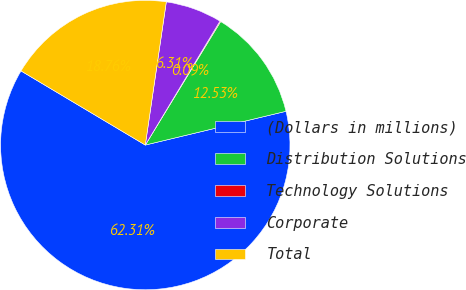<chart> <loc_0><loc_0><loc_500><loc_500><pie_chart><fcel>(Dollars in millions)<fcel>Distribution Solutions<fcel>Technology Solutions<fcel>Corporate<fcel>Total<nl><fcel>62.3%<fcel>12.53%<fcel>0.09%<fcel>6.31%<fcel>18.76%<nl></chart> 